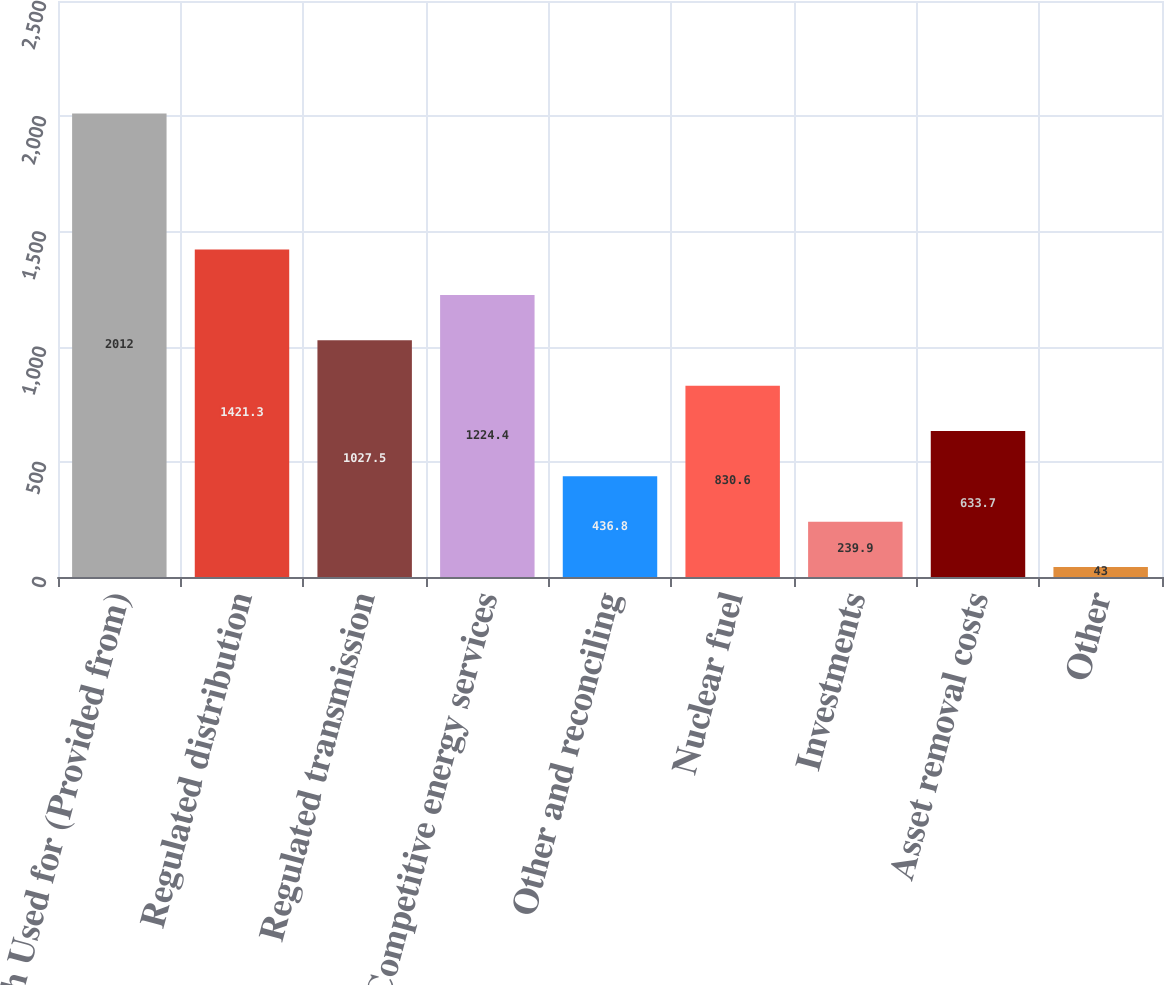<chart> <loc_0><loc_0><loc_500><loc_500><bar_chart><fcel>Cash Used for (Provided from)<fcel>Regulated distribution<fcel>Regulated transmission<fcel>Competitive energy services<fcel>Other and reconciling<fcel>Nuclear fuel<fcel>Investments<fcel>Asset removal costs<fcel>Other<nl><fcel>2012<fcel>1421.3<fcel>1027.5<fcel>1224.4<fcel>436.8<fcel>830.6<fcel>239.9<fcel>633.7<fcel>43<nl></chart> 